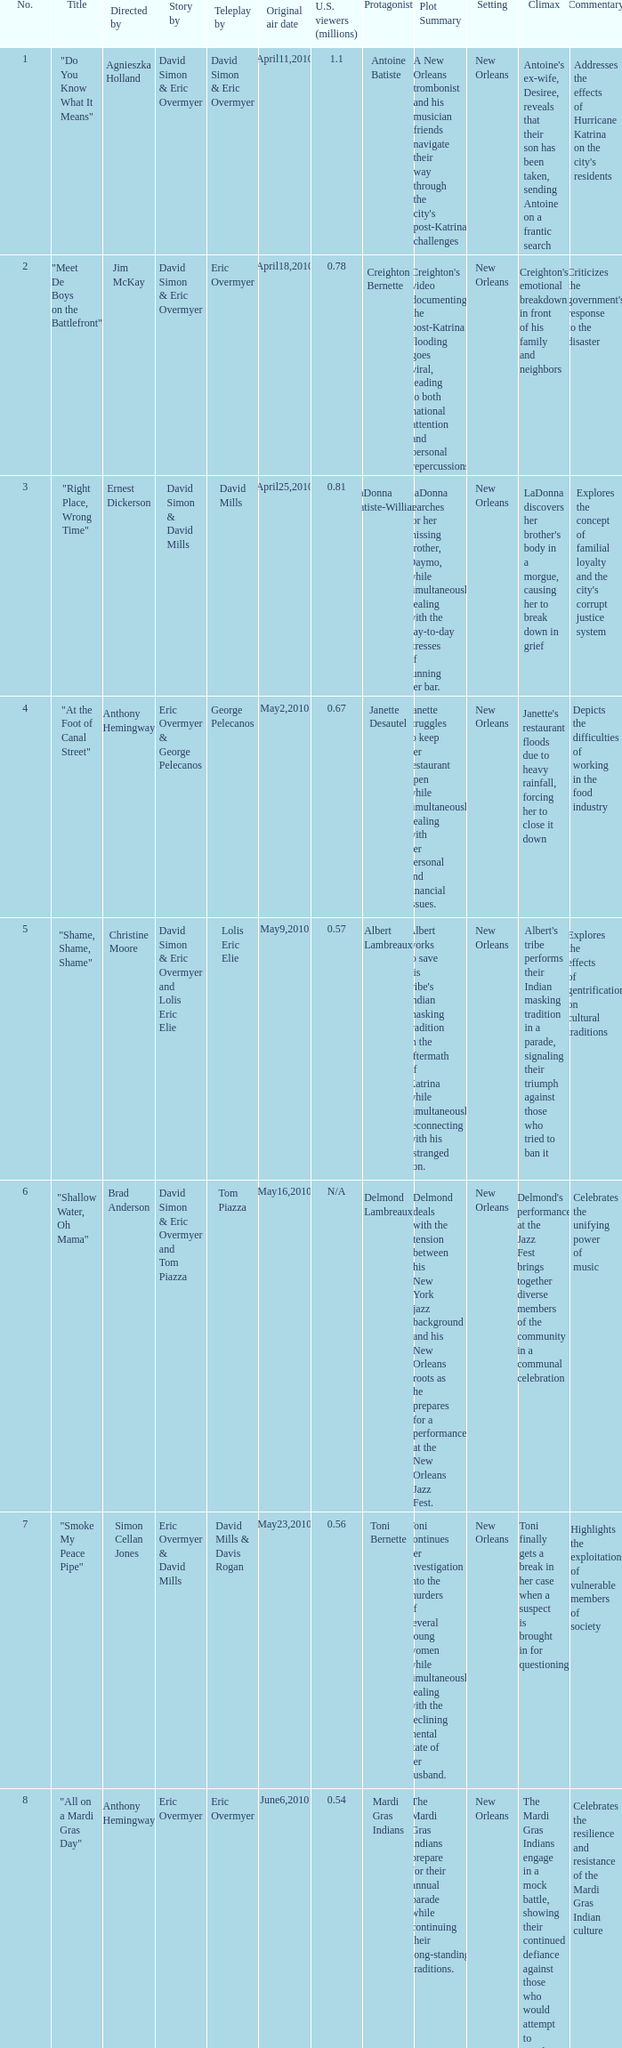Name the number for simon cellan jones 7.0. 